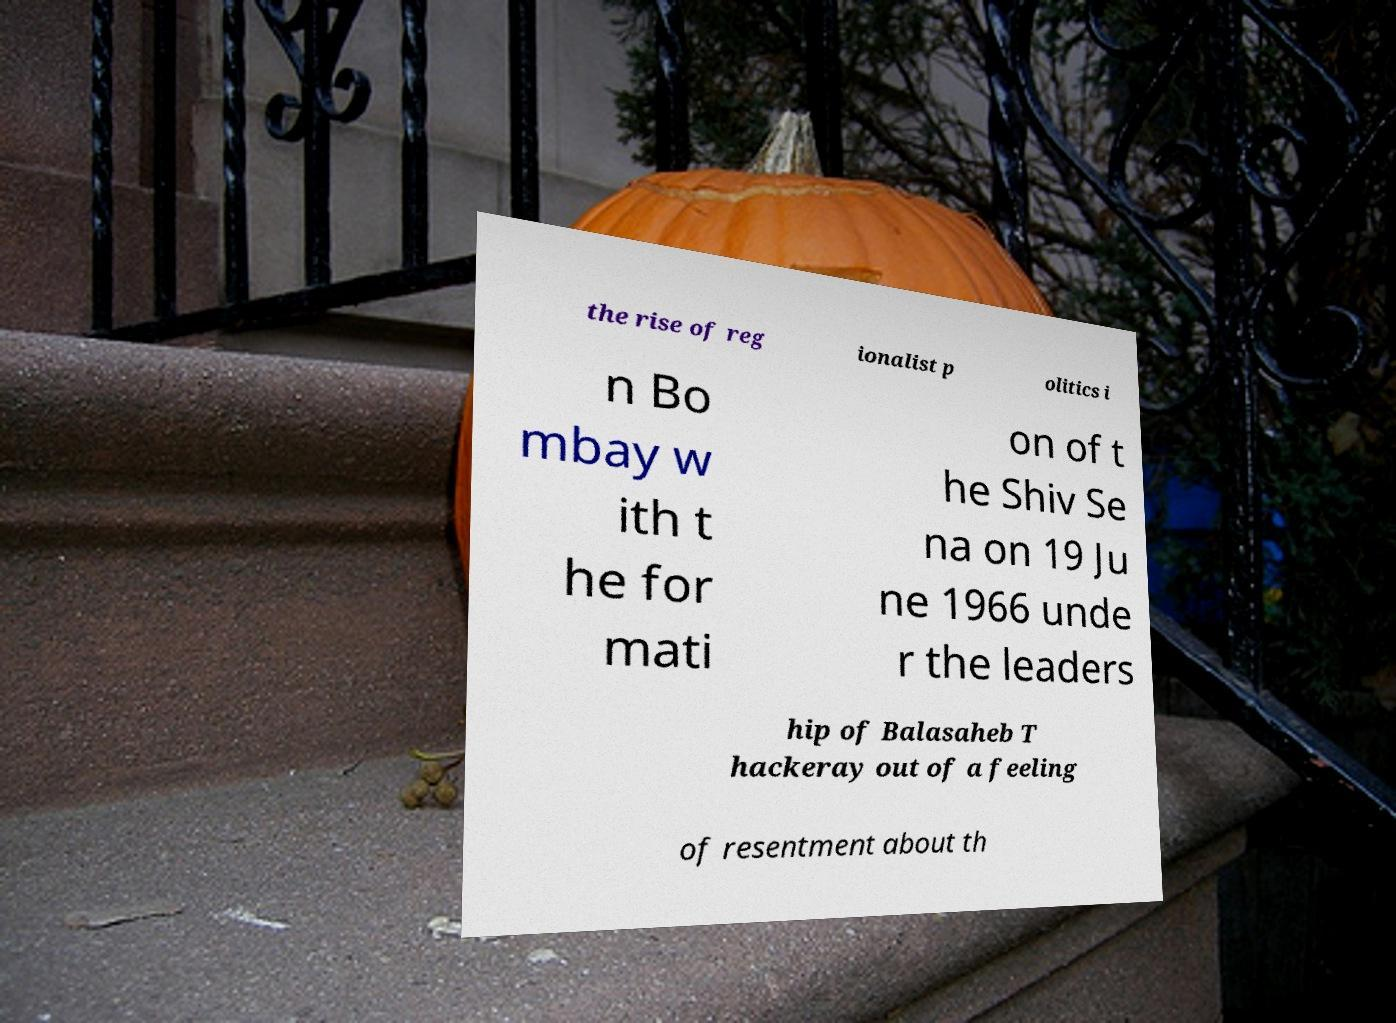For documentation purposes, I need the text within this image transcribed. Could you provide that? the rise of reg ionalist p olitics i n Bo mbay w ith t he for mati on of t he Shiv Se na on 19 Ju ne 1966 unde r the leaders hip of Balasaheb T hackeray out of a feeling of resentment about th 